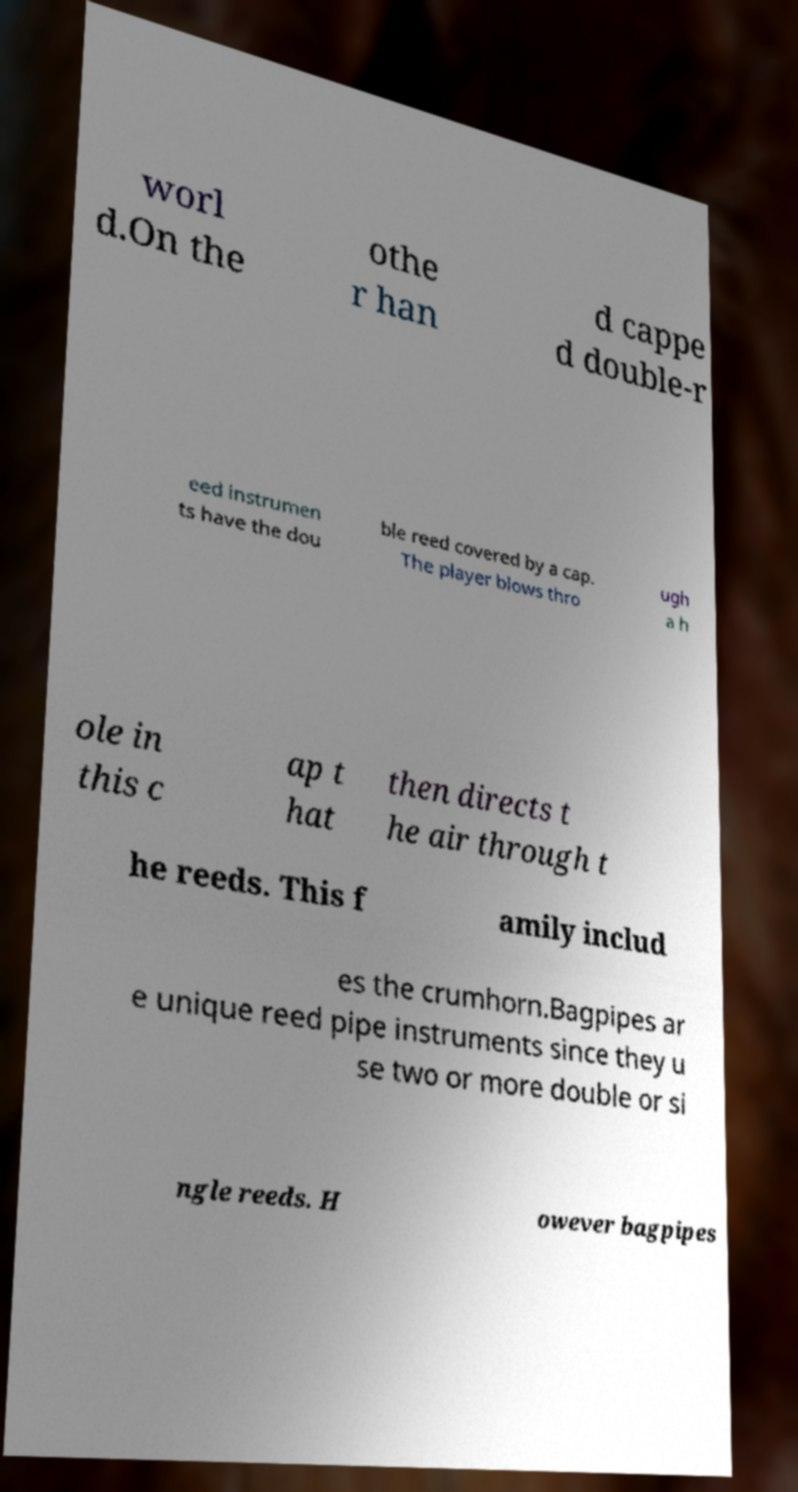Can you accurately transcribe the text from the provided image for me? worl d.On the othe r han d cappe d double-r eed instrumen ts have the dou ble reed covered by a cap. The player blows thro ugh a h ole in this c ap t hat then directs t he air through t he reeds. This f amily includ es the crumhorn.Bagpipes ar e unique reed pipe instruments since they u se two or more double or si ngle reeds. H owever bagpipes 